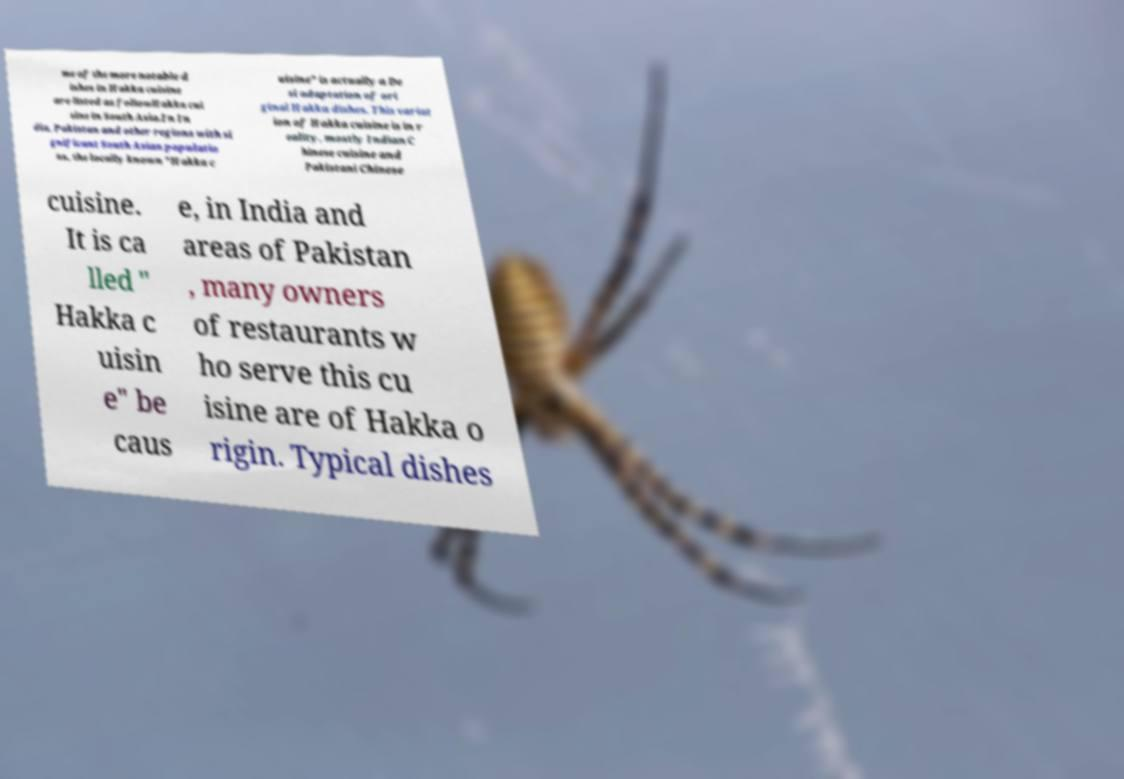Could you assist in decoding the text presented in this image and type it out clearly? me of the more notable d ishes in Hakka cuisine are listed as followHakka cui sine in South Asia.In In dia, Pakistan and other regions with si gnificant South Asian populatio ns, the locally known "Hakka c uisine" is actually a De si adaptation of ori ginal Hakka dishes. This variat ion of Hakka cuisine is in r eality, mostly Indian C hinese cuisine and Pakistani Chinese cuisine. It is ca lled " Hakka c uisin e" be caus e, in India and areas of Pakistan , many owners of restaurants w ho serve this cu isine are of Hakka o rigin. Typical dishes 